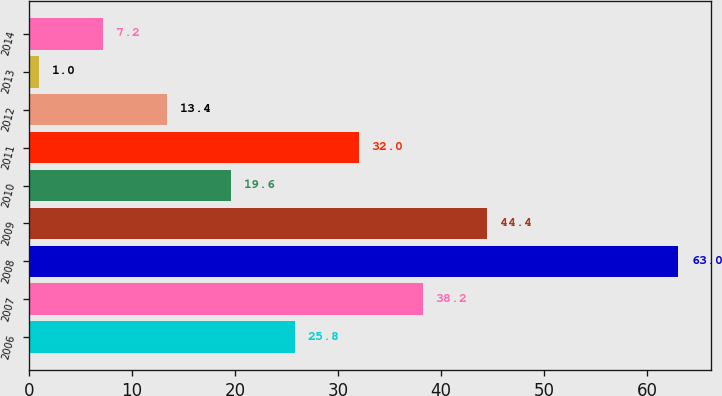<chart> <loc_0><loc_0><loc_500><loc_500><bar_chart><fcel>2006<fcel>2007<fcel>2008<fcel>2009<fcel>2010<fcel>2011<fcel>2012<fcel>2013<fcel>2014<nl><fcel>25.8<fcel>38.2<fcel>63<fcel>44.4<fcel>19.6<fcel>32<fcel>13.4<fcel>1<fcel>7.2<nl></chart> 